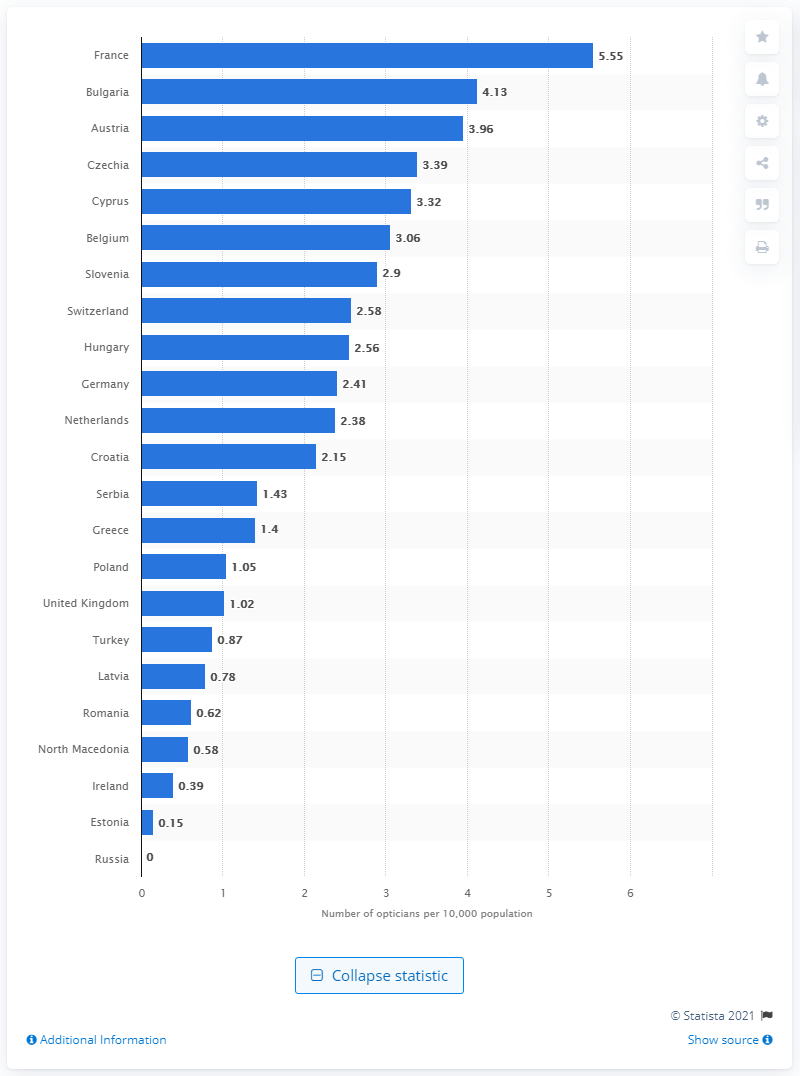Specify some key components in this picture. In 2020, there were an estimated 5.55 opticians per 10,000 population in France. According to the information provided, Cyprus has the highest number of optician retail outlets. 